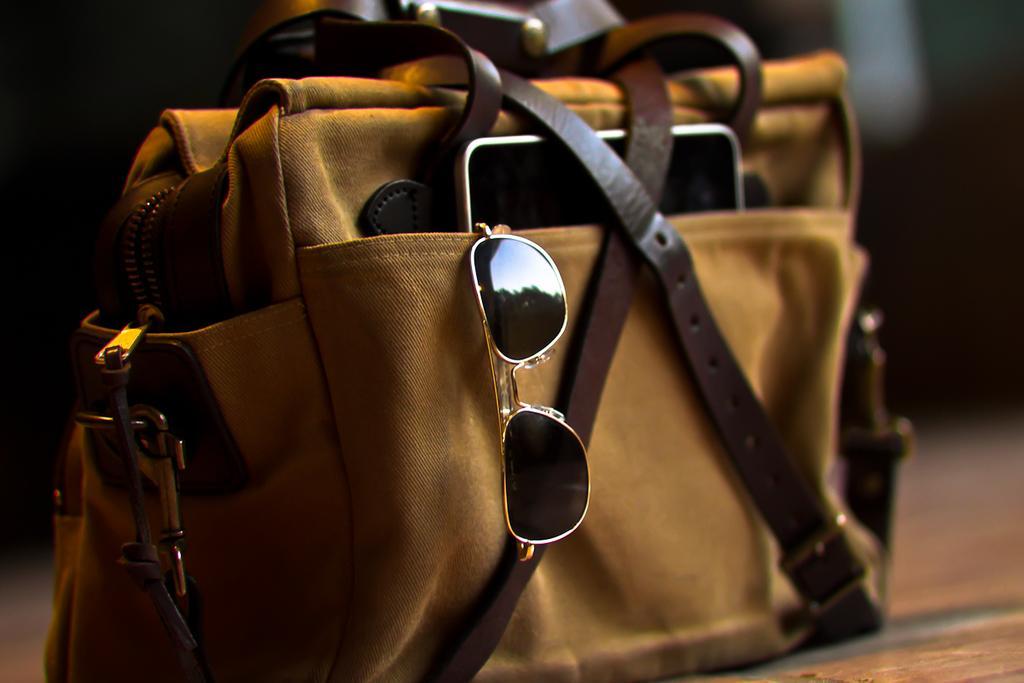How would you summarize this image in a sentence or two? In the image there is a bag which is in yellow color. Inside a bag we can see a mobile and goggles and its strips are in brown color. 